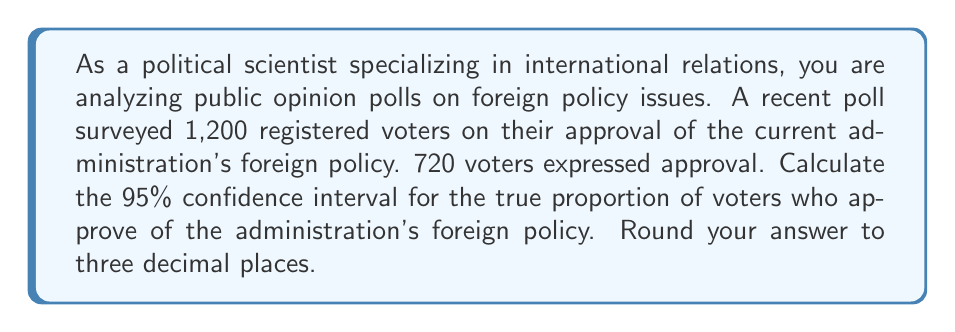Can you solve this math problem? To calculate the confidence interval, we'll use the formula for the margin of error in a proportion:

$$ \text{Margin of Error} = z \sqrt{\frac{p(1-p)}{n}} $$

Where:
- $z$ is the z-score for the desired confidence level (1.96 for 95% confidence)
- $p$ is the sample proportion
- $n$ is the sample size

Steps:
1. Calculate the sample proportion:
   $p = \frac{720}{1200} = 0.6$

2. Calculate the margin of error:
   $$ \text{ME} = 1.96 \sqrt{\frac{0.6(1-0.6)}{1200}} = 1.96 \sqrt{\frac{0.24}{1200}} = 1.96 \sqrt{0.0002} \approx 0.0277 $$

3. Calculate the confidence interval:
   Lower bound: $0.6 - 0.0277 = 0.5723$
   Upper bound: $0.6 + 0.0277 = 0.6277$

4. Round to three decimal places:
   (0.572, 0.628)

This means we can be 95% confident that the true proportion of voters who approve of the administration's foreign policy falls between 57.2% and 62.8%.
Answer: (0.572, 0.628) 